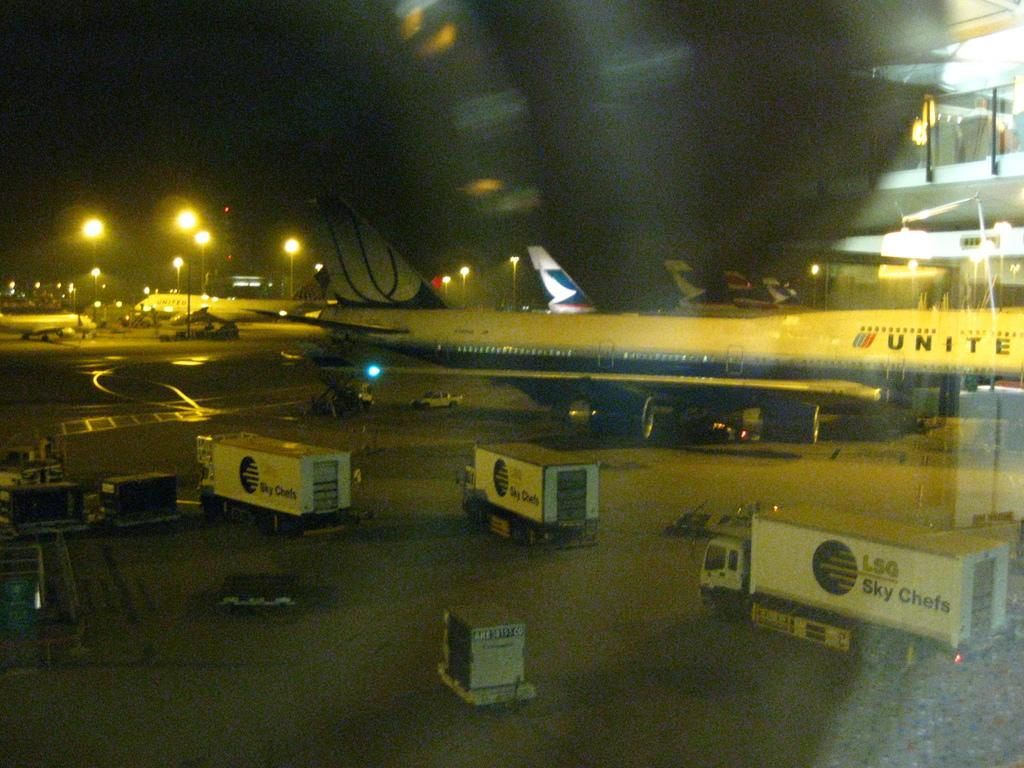What vehicles are in the foreground of the image? There are trucks in the foreground of the image. What type of transportation can be seen in the background of the image? There are aircraft in the background of the image. What structures are present in the background of the image? There are lamp poles in the background of the image. What is visible in the sky in the background of the image? The sky is visible in the background of the image. Can you tell me how many insects are crawling on the trucks in the image? There are no insects visible on the trucks in the image. What type of property is being sold in the image? There is no property being sold in the image; it features trucks, aircraft, lamp poles, and the sky. 